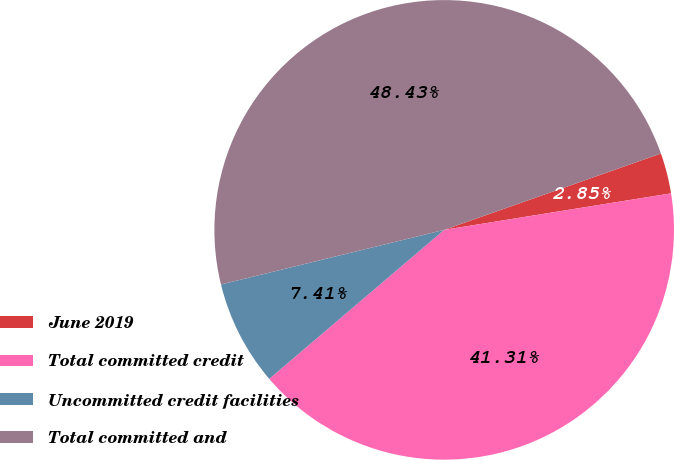Convert chart. <chart><loc_0><loc_0><loc_500><loc_500><pie_chart><fcel>June 2019<fcel>Total committed credit<fcel>Uncommitted credit facilities<fcel>Total committed and<nl><fcel>2.85%<fcel>41.31%<fcel>7.41%<fcel>48.43%<nl></chart> 